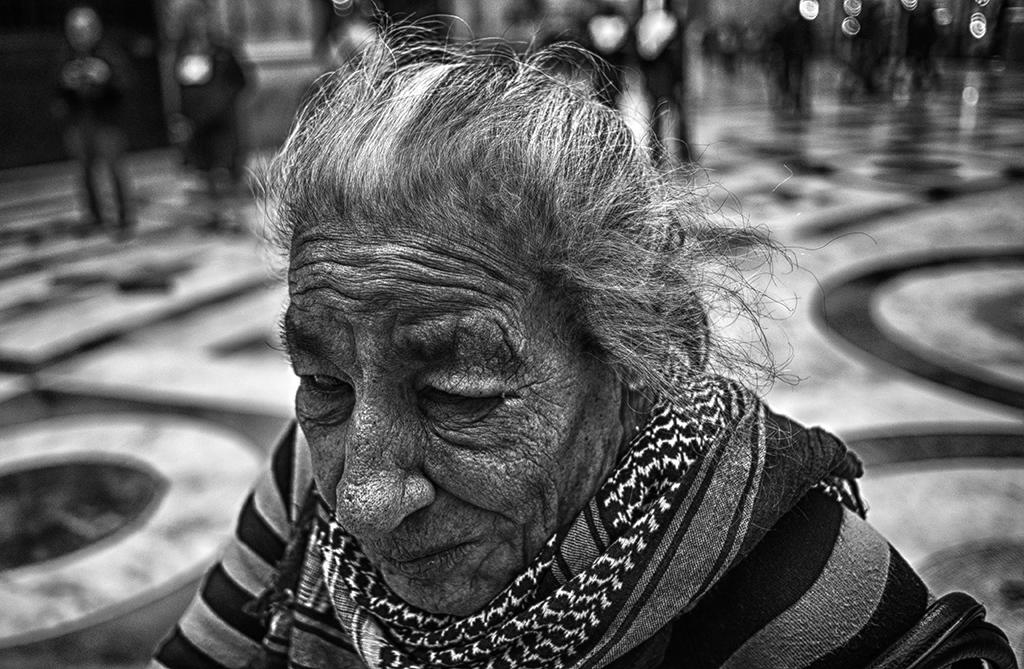Who is the main subject in the image? There is an old woman in the image. What is the old woman wearing around her neck? The old woman is wearing a scarf around her neck. Can you describe the people in the background of the image? The background of the image is blurred, so it is difficult to see the people clearly. What type of silk is being used to make the old woman's scarf in the image? There is no information about the type of silk used for the scarf in the image. How long does the fight between the old woman and the people in the background last? There is no fight depicted in the image; it only shows the old woman and some blurred people in the background. 